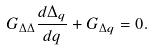Convert formula to latex. <formula><loc_0><loc_0><loc_500><loc_500>G _ { \Delta \Delta } \frac { d \Delta _ { q } } { d q } + G _ { \Delta q } = 0 .</formula> 